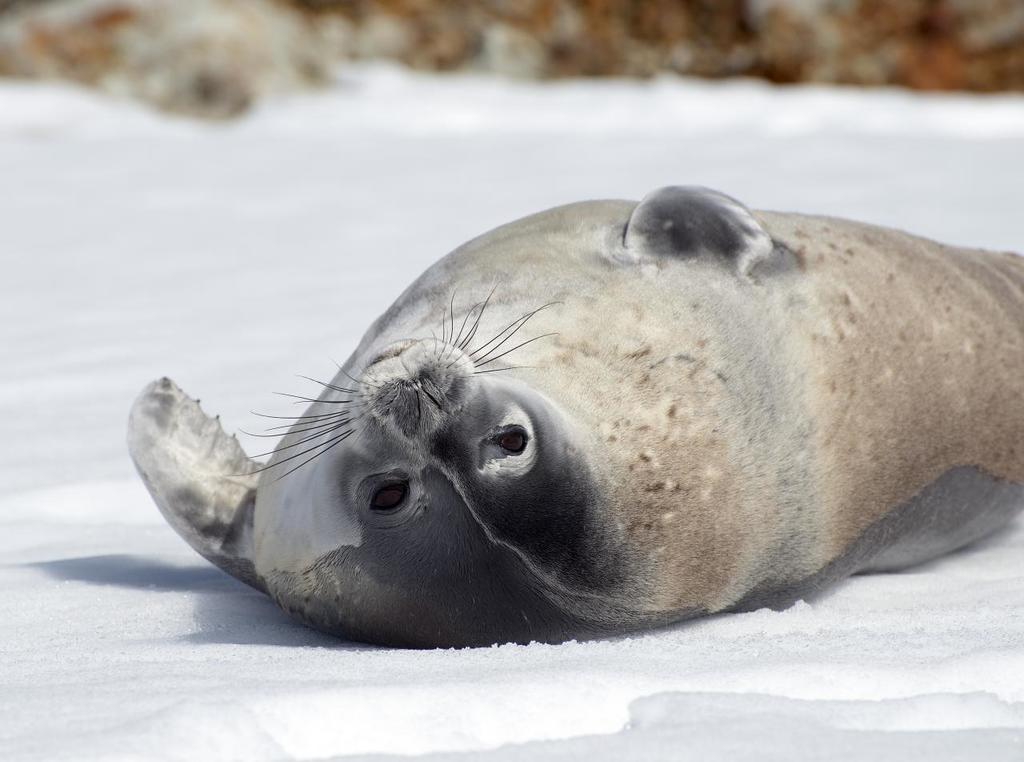What type of animal is in the image? There is a seal animal in the image. Where is the seal animal located in the image? The seal animal is on the floor in the center of the image. What is the ground made of in the image? There is snow on the ground in the image. How would you describe the background of the image? The background of the image is blurry. Can you see a person wearing a shoe in the image? There is no person or shoe present in the image; it features a seal animal on the snowy ground. 